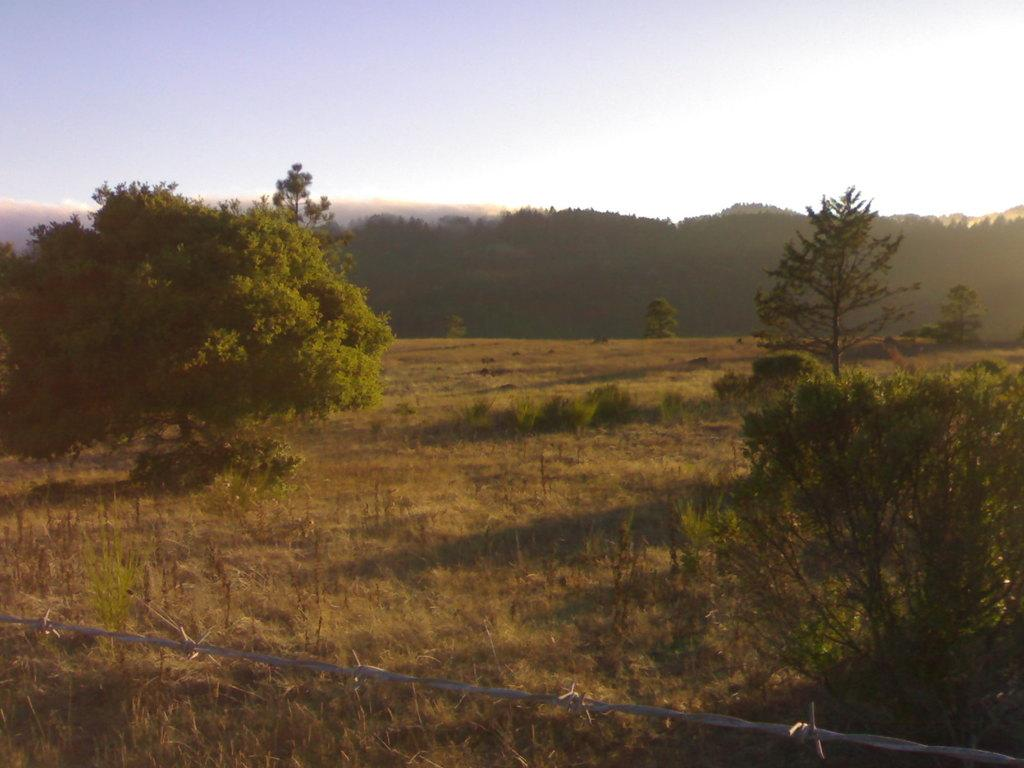What type of surface can be seen in the image? The ground is visible in the image. What is covering the ground? There is grass on the ground. What type of barrier is present in the image? There is a metal fence in the image. What type of vegetation is present in the image? There are green trees in the image. What can be seen in the distance in the image? The sky is visible in the background of the image. What type of paint is being used to create the trees in the image? There is no paint present in the image; the trees are real and not painted. What type of produce is being harvested in the image? There is no produce being harvested in the image; the focus is on the trees and the sky. 